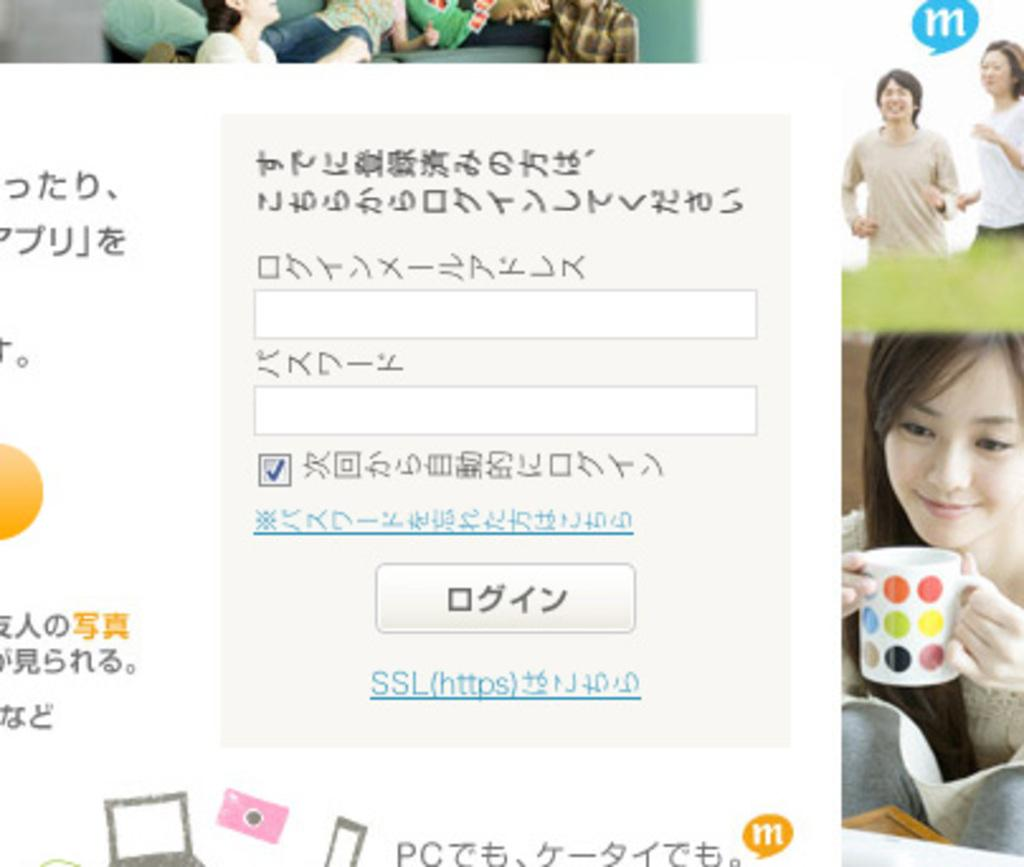What is the main subject of the poster in the image? The poster contains an image of a woman holding a coffee cup. What other activities are depicted on the poster? The poster shows two people running. What can be found alongside the images on the poster? There is text with images on the poster. What types of images are included on the poster? The poster includes images of people and objects on a surface. How many babies are visible on the poster? There are no babies present on the poster; it features images of people and objects related to coffee and running. 